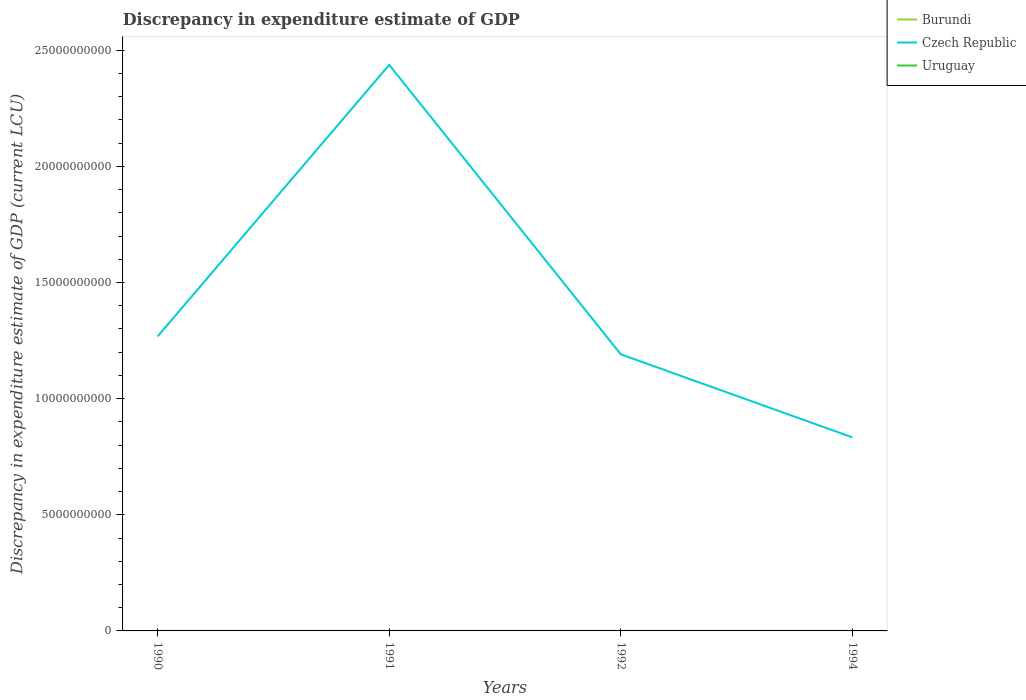Does the line corresponding to Uruguay intersect with the line corresponding to Burundi?
Provide a short and direct response. Yes. Across all years, what is the maximum discrepancy in expenditure estimate of GDP in Burundi?
Your answer should be compact. 0. What is the total discrepancy in expenditure estimate of GDP in Burundi in the graph?
Your answer should be very brief. 1.00e+05. What is the difference between the highest and the second highest discrepancy in expenditure estimate of GDP in Czech Republic?
Your answer should be very brief. 1.60e+1. What is the difference between the highest and the lowest discrepancy in expenditure estimate of GDP in Uruguay?
Make the answer very short. 2. Is the discrepancy in expenditure estimate of GDP in Uruguay strictly greater than the discrepancy in expenditure estimate of GDP in Burundi over the years?
Your answer should be very brief. No. How many lines are there?
Give a very brief answer. 3. How many years are there in the graph?
Your answer should be very brief. 4. What is the difference between two consecutive major ticks on the Y-axis?
Provide a short and direct response. 5.00e+09. Are the values on the major ticks of Y-axis written in scientific E-notation?
Offer a very short reply. No. How many legend labels are there?
Keep it short and to the point. 3. What is the title of the graph?
Your answer should be compact. Discrepancy in expenditure estimate of GDP. What is the label or title of the X-axis?
Offer a terse response. Years. What is the label or title of the Y-axis?
Your response must be concise. Discrepancy in expenditure estimate of GDP (current LCU). What is the Discrepancy in expenditure estimate of GDP (current LCU) in Burundi in 1990?
Provide a short and direct response. 0. What is the Discrepancy in expenditure estimate of GDP (current LCU) in Czech Republic in 1990?
Your answer should be very brief. 1.27e+1. What is the Discrepancy in expenditure estimate of GDP (current LCU) of Uruguay in 1990?
Offer a very short reply. 2.7e-6. What is the Discrepancy in expenditure estimate of GDP (current LCU) in Burundi in 1991?
Ensure brevity in your answer.  1.00e+05. What is the Discrepancy in expenditure estimate of GDP (current LCU) in Czech Republic in 1991?
Make the answer very short. 2.44e+1. What is the Discrepancy in expenditure estimate of GDP (current LCU) of Uruguay in 1991?
Give a very brief answer. 4e-6. What is the Discrepancy in expenditure estimate of GDP (current LCU) of Burundi in 1992?
Your response must be concise. 6e-5. What is the Discrepancy in expenditure estimate of GDP (current LCU) in Czech Republic in 1992?
Offer a terse response. 1.19e+1. What is the Discrepancy in expenditure estimate of GDP (current LCU) in Uruguay in 1992?
Your response must be concise. 0. What is the Discrepancy in expenditure estimate of GDP (current LCU) in Burundi in 1994?
Your response must be concise. 0. What is the Discrepancy in expenditure estimate of GDP (current LCU) in Czech Republic in 1994?
Your response must be concise. 8.33e+09. Across all years, what is the maximum Discrepancy in expenditure estimate of GDP (current LCU) of Burundi?
Keep it short and to the point. 1.00e+05. Across all years, what is the maximum Discrepancy in expenditure estimate of GDP (current LCU) in Czech Republic?
Make the answer very short. 2.44e+1. Across all years, what is the maximum Discrepancy in expenditure estimate of GDP (current LCU) in Uruguay?
Ensure brevity in your answer.  4e-6. Across all years, what is the minimum Discrepancy in expenditure estimate of GDP (current LCU) of Burundi?
Ensure brevity in your answer.  0. Across all years, what is the minimum Discrepancy in expenditure estimate of GDP (current LCU) in Czech Republic?
Ensure brevity in your answer.  8.33e+09. Across all years, what is the minimum Discrepancy in expenditure estimate of GDP (current LCU) of Uruguay?
Provide a short and direct response. 0. What is the total Discrepancy in expenditure estimate of GDP (current LCU) in Burundi in the graph?
Give a very brief answer. 1.00e+05. What is the total Discrepancy in expenditure estimate of GDP (current LCU) of Czech Republic in the graph?
Make the answer very short. 5.73e+1. What is the difference between the Discrepancy in expenditure estimate of GDP (current LCU) of Czech Republic in 1990 and that in 1991?
Ensure brevity in your answer.  -1.17e+1. What is the difference between the Discrepancy in expenditure estimate of GDP (current LCU) of Czech Republic in 1990 and that in 1992?
Keep it short and to the point. 7.69e+08. What is the difference between the Discrepancy in expenditure estimate of GDP (current LCU) in Czech Republic in 1990 and that in 1994?
Give a very brief answer. 4.35e+09. What is the difference between the Discrepancy in expenditure estimate of GDP (current LCU) in Burundi in 1991 and that in 1992?
Your answer should be compact. 1.00e+05. What is the difference between the Discrepancy in expenditure estimate of GDP (current LCU) in Czech Republic in 1991 and that in 1992?
Give a very brief answer. 1.25e+1. What is the difference between the Discrepancy in expenditure estimate of GDP (current LCU) in Czech Republic in 1991 and that in 1994?
Your answer should be very brief. 1.60e+1. What is the difference between the Discrepancy in expenditure estimate of GDP (current LCU) in Czech Republic in 1992 and that in 1994?
Give a very brief answer. 3.58e+09. What is the difference between the Discrepancy in expenditure estimate of GDP (current LCU) in Czech Republic in 1990 and the Discrepancy in expenditure estimate of GDP (current LCU) in Uruguay in 1991?
Your answer should be compact. 1.27e+1. What is the difference between the Discrepancy in expenditure estimate of GDP (current LCU) in Burundi in 1991 and the Discrepancy in expenditure estimate of GDP (current LCU) in Czech Republic in 1992?
Ensure brevity in your answer.  -1.19e+1. What is the difference between the Discrepancy in expenditure estimate of GDP (current LCU) in Burundi in 1991 and the Discrepancy in expenditure estimate of GDP (current LCU) in Czech Republic in 1994?
Give a very brief answer. -8.33e+09. What is the difference between the Discrepancy in expenditure estimate of GDP (current LCU) of Burundi in 1992 and the Discrepancy in expenditure estimate of GDP (current LCU) of Czech Republic in 1994?
Give a very brief answer. -8.33e+09. What is the average Discrepancy in expenditure estimate of GDP (current LCU) in Burundi per year?
Your response must be concise. 2.50e+04. What is the average Discrepancy in expenditure estimate of GDP (current LCU) in Czech Republic per year?
Provide a succinct answer. 1.43e+1. What is the average Discrepancy in expenditure estimate of GDP (current LCU) of Uruguay per year?
Keep it short and to the point. 0. In the year 1990, what is the difference between the Discrepancy in expenditure estimate of GDP (current LCU) of Czech Republic and Discrepancy in expenditure estimate of GDP (current LCU) of Uruguay?
Offer a terse response. 1.27e+1. In the year 1991, what is the difference between the Discrepancy in expenditure estimate of GDP (current LCU) in Burundi and Discrepancy in expenditure estimate of GDP (current LCU) in Czech Republic?
Ensure brevity in your answer.  -2.44e+1. In the year 1991, what is the difference between the Discrepancy in expenditure estimate of GDP (current LCU) in Burundi and Discrepancy in expenditure estimate of GDP (current LCU) in Uruguay?
Your response must be concise. 1.00e+05. In the year 1991, what is the difference between the Discrepancy in expenditure estimate of GDP (current LCU) in Czech Republic and Discrepancy in expenditure estimate of GDP (current LCU) in Uruguay?
Offer a terse response. 2.44e+1. In the year 1992, what is the difference between the Discrepancy in expenditure estimate of GDP (current LCU) in Burundi and Discrepancy in expenditure estimate of GDP (current LCU) in Czech Republic?
Provide a succinct answer. -1.19e+1. What is the ratio of the Discrepancy in expenditure estimate of GDP (current LCU) in Czech Republic in 1990 to that in 1991?
Your response must be concise. 0.52. What is the ratio of the Discrepancy in expenditure estimate of GDP (current LCU) in Uruguay in 1990 to that in 1991?
Your answer should be very brief. 0.68. What is the ratio of the Discrepancy in expenditure estimate of GDP (current LCU) in Czech Republic in 1990 to that in 1992?
Provide a short and direct response. 1.06. What is the ratio of the Discrepancy in expenditure estimate of GDP (current LCU) of Czech Republic in 1990 to that in 1994?
Give a very brief answer. 1.52. What is the ratio of the Discrepancy in expenditure estimate of GDP (current LCU) in Burundi in 1991 to that in 1992?
Give a very brief answer. 1.67e+09. What is the ratio of the Discrepancy in expenditure estimate of GDP (current LCU) of Czech Republic in 1991 to that in 1992?
Provide a short and direct response. 2.05. What is the ratio of the Discrepancy in expenditure estimate of GDP (current LCU) in Czech Republic in 1991 to that in 1994?
Your response must be concise. 2.92. What is the ratio of the Discrepancy in expenditure estimate of GDP (current LCU) in Czech Republic in 1992 to that in 1994?
Provide a short and direct response. 1.43. What is the difference between the highest and the second highest Discrepancy in expenditure estimate of GDP (current LCU) of Czech Republic?
Offer a very short reply. 1.17e+1. What is the difference between the highest and the lowest Discrepancy in expenditure estimate of GDP (current LCU) in Burundi?
Offer a very short reply. 1.00e+05. What is the difference between the highest and the lowest Discrepancy in expenditure estimate of GDP (current LCU) of Czech Republic?
Give a very brief answer. 1.60e+1. 